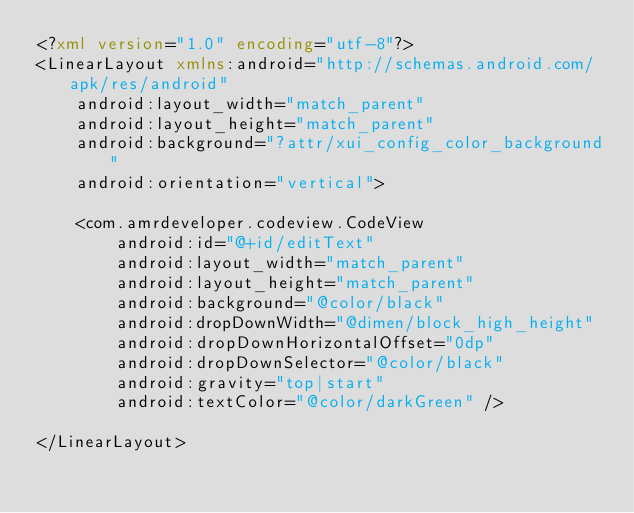Convert code to text. <code><loc_0><loc_0><loc_500><loc_500><_XML_><?xml version="1.0" encoding="utf-8"?>
<LinearLayout xmlns:android="http://schemas.android.com/apk/res/android"
    android:layout_width="match_parent"
    android:layout_height="match_parent"
    android:background="?attr/xui_config_color_background"
    android:orientation="vertical">

    <com.amrdeveloper.codeview.CodeView
        android:id="@+id/editText"
        android:layout_width="match_parent"
        android:layout_height="match_parent"
        android:background="@color/black"
        android:dropDownWidth="@dimen/block_high_height"
        android:dropDownHorizontalOffset="0dp"
        android:dropDownSelector="@color/black"
        android:gravity="top|start"
        android:textColor="@color/darkGreen" />

</LinearLayout></code> 